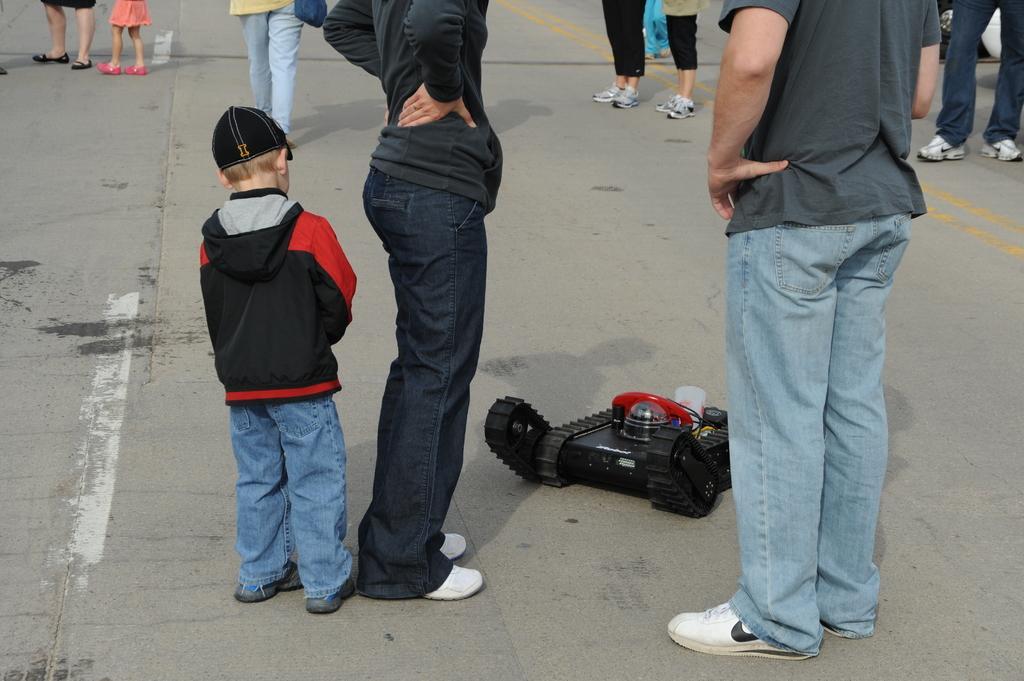How would you summarize this image in a sentence or two? In this picture there are people and we can see a toy vehicle on the road. 